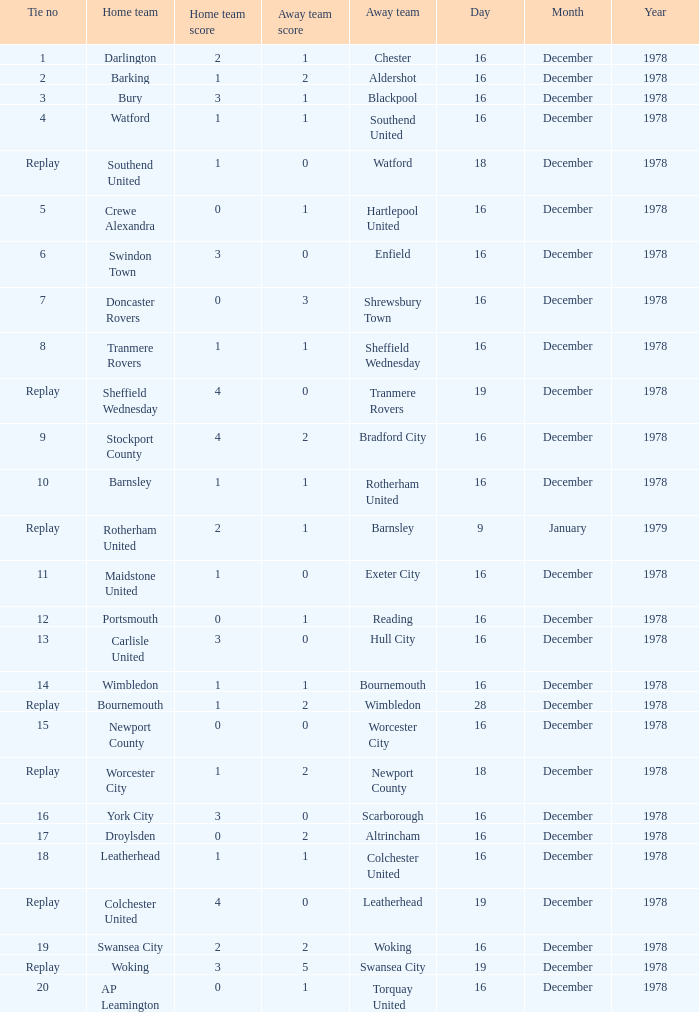Could you help me parse every detail presented in this table? {'header': ['Tie no', 'Home team', 'Home team score', 'Away team score', 'Away team', 'Day', 'Month', 'Year'], 'rows': [['1', 'Darlington', '2', '1', 'Chester', '16', 'December', '1978'], ['2', 'Barking', '1', '2', 'Aldershot', '16', 'December', '1978'], ['3', 'Bury', '3', '1', 'Blackpool', '16', 'December', '1978'], ['4', 'Watford', '1', '1', 'Southend United', '16', 'December', '1978'], ['Replay', 'Southend United', '1', '0', 'Watford', '18', 'December', '1978'], ['5', 'Crewe Alexandra', '0', '1', 'Hartlepool United', '16', 'December', '1978'], ['6', 'Swindon Town', '3', '0', 'Enfield', '16', 'December', '1978'], ['7', 'Doncaster Rovers', '0', '3', 'Shrewsbury Town', '16', 'December', '1978'], ['8', 'Tranmere Rovers', '1', '1', 'Sheffield Wednesday', '16', 'December', '1978'], ['Replay', 'Sheffield Wednesday', '4', '0', 'Tranmere Rovers', '19', 'December', '1978'], ['9', 'Stockport County', '4', '2', 'Bradford City', '16', 'December', '1978'], ['10', 'Barnsley', '1', '1', 'Rotherham United', '16', 'December', '1978'], ['Replay', 'Rotherham United', '2', '1', 'Barnsley', '9', 'January', '1979'], ['11', 'Maidstone United', '1', '0', 'Exeter City', '16', 'December', '1978'], ['12', 'Portsmouth', '0', '1', 'Reading', '16', 'December', '1978'], ['13', 'Carlisle United', '3', '0', 'Hull City', '16', 'December', '1978'], ['14', 'Wimbledon', '1', '1', 'Bournemouth', '16', 'December', '1978'], ['Replay', 'Bournemouth', '1', '2', 'Wimbledon', '28', 'December', '1978'], ['15', 'Newport County', '0', '0', 'Worcester City', '16', 'December', '1978'], ['Replay', 'Worcester City', '1', '2', 'Newport County', '18', 'December', '1978'], ['16', 'York City', '3', '0', 'Scarborough', '16', 'December', '1978'], ['17', 'Droylsden', '0', '2', 'Altrincham', '16', 'December', '1978'], ['18', 'Leatherhead', '1', '1', 'Colchester United', '16', 'December', '1978'], ['Replay', 'Colchester United', '4', '0', 'Leatherhead', '19', 'December', '1978'], ['19', 'Swansea City', '2', '2', 'Woking', '16', 'December', '1978'], ['Replay', 'Woking', '3', '5', 'Swansea City', '19', 'December', '1978'], ['20', 'AP Leamington', '0', '1', 'Torquay United', '16', 'December', '1978']]} What is the score for the date of 16 december 1978, with a tie no of 9? 4–2. 